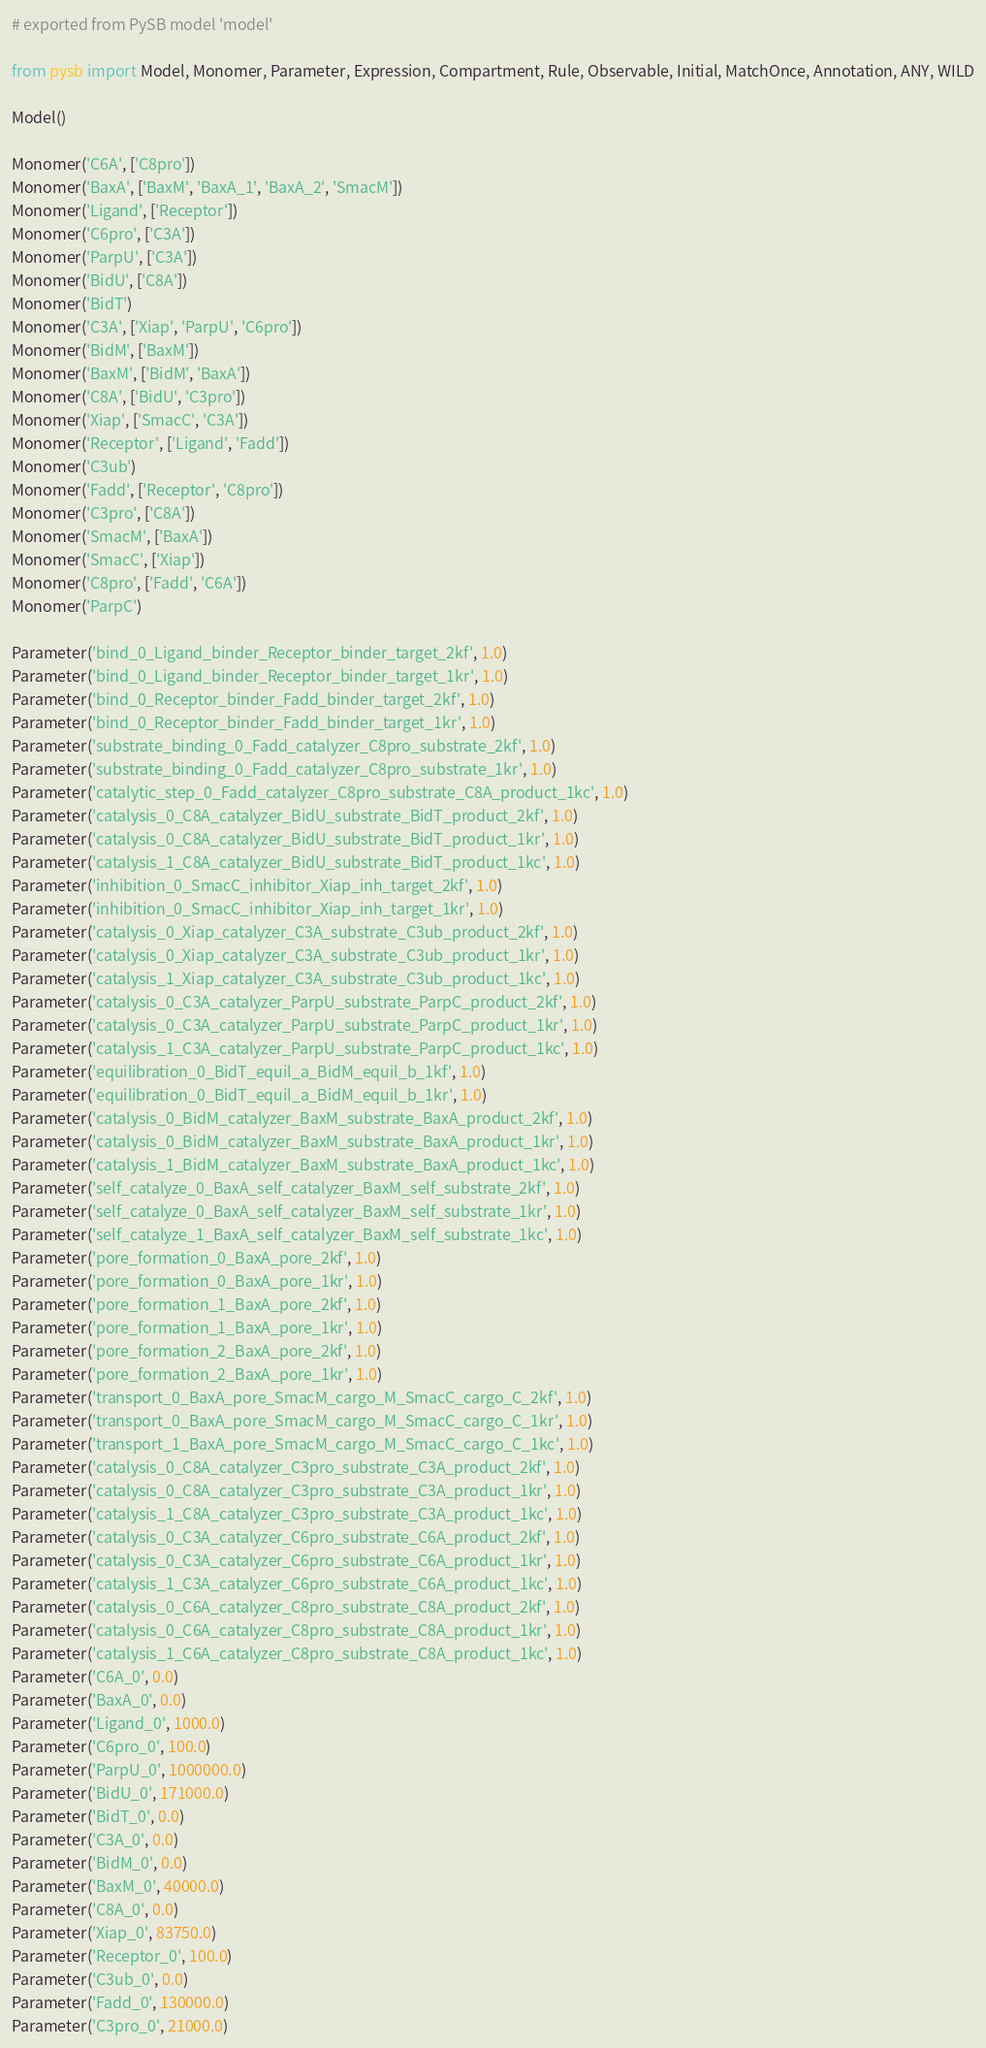<code> <loc_0><loc_0><loc_500><loc_500><_Python_># exported from PySB model 'model'

from pysb import Model, Monomer, Parameter, Expression, Compartment, Rule, Observable, Initial, MatchOnce, Annotation, ANY, WILD

Model()

Monomer('C6A', ['C8pro'])
Monomer('BaxA', ['BaxM', 'BaxA_1', 'BaxA_2', 'SmacM'])
Monomer('Ligand', ['Receptor'])
Monomer('C6pro', ['C3A'])
Monomer('ParpU', ['C3A'])
Monomer('BidU', ['C8A'])
Monomer('BidT')
Monomer('C3A', ['Xiap', 'ParpU', 'C6pro'])
Monomer('BidM', ['BaxM'])
Monomer('BaxM', ['BidM', 'BaxA'])
Monomer('C8A', ['BidU', 'C3pro'])
Monomer('Xiap', ['SmacC', 'C3A'])
Monomer('Receptor', ['Ligand', 'Fadd'])
Monomer('C3ub')
Monomer('Fadd', ['Receptor', 'C8pro'])
Monomer('C3pro', ['C8A'])
Monomer('SmacM', ['BaxA'])
Monomer('SmacC', ['Xiap'])
Monomer('C8pro', ['Fadd', 'C6A'])
Monomer('ParpC')

Parameter('bind_0_Ligand_binder_Receptor_binder_target_2kf', 1.0)
Parameter('bind_0_Ligand_binder_Receptor_binder_target_1kr', 1.0)
Parameter('bind_0_Receptor_binder_Fadd_binder_target_2kf', 1.0)
Parameter('bind_0_Receptor_binder_Fadd_binder_target_1kr', 1.0)
Parameter('substrate_binding_0_Fadd_catalyzer_C8pro_substrate_2kf', 1.0)
Parameter('substrate_binding_0_Fadd_catalyzer_C8pro_substrate_1kr', 1.0)
Parameter('catalytic_step_0_Fadd_catalyzer_C8pro_substrate_C8A_product_1kc', 1.0)
Parameter('catalysis_0_C8A_catalyzer_BidU_substrate_BidT_product_2kf', 1.0)
Parameter('catalysis_0_C8A_catalyzer_BidU_substrate_BidT_product_1kr', 1.0)
Parameter('catalysis_1_C8A_catalyzer_BidU_substrate_BidT_product_1kc', 1.0)
Parameter('inhibition_0_SmacC_inhibitor_Xiap_inh_target_2kf', 1.0)
Parameter('inhibition_0_SmacC_inhibitor_Xiap_inh_target_1kr', 1.0)
Parameter('catalysis_0_Xiap_catalyzer_C3A_substrate_C3ub_product_2kf', 1.0)
Parameter('catalysis_0_Xiap_catalyzer_C3A_substrate_C3ub_product_1kr', 1.0)
Parameter('catalysis_1_Xiap_catalyzer_C3A_substrate_C3ub_product_1kc', 1.0)
Parameter('catalysis_0_C3A_catalyzer_ParpU_substrate_ParpC_product_2kf', 1.0)
Parameter('catalysis_0_C3A_catalyzer_ParpU_substrate_ParpC_product_1kr', 1.0)
Parameter('catalysis_1_C3A_catalyzer_ParpU_substrate_ParpC_product_1kc', 1.0)
Parameter('equilibration_0_BidT_equil_a_BidM_equil_b_1kf', 1.0)
Parameter('equilibration_0_BidT_equil_a_BidM_equil_b_1kr', 1.0)
Parameter('catalysis_0_BidM_catalyzer_BaxM_substrate_BaxA_product_2kf', 1.0)
Parameter('catalysis_0_BidM_catalyzer_BaxM_substrate_BaxA_product_1kr', 1.0)
Parameter('catalysis_1_BidM_catalyzer_BaxM_substrate_BaxA_product_1kc', 1.0)
Parameter('self_catalyze_0_BaxA_self_catalyzer_BaxM_self_substrate_2kf', 1.0)
Parameter('self_catalyze_0_BaxA_self_catalyzer_BaxM_self_substrate_1kr', 1.0)
Parameter('self_catalyze_1_BaxA_self_catalyzer_BaxM_self_substrate_1kc', 1.0)
Parameter('pore_formation_0_BaxA_pore_2kf', 1.0)
Parameter('pore_formation_0_BaxA_pore_1kr', 1.0)
Parameter('pore_formation_1_BaxA_pore_2kf', 1.0)
Parameter('pore_formation_1_BaxA_pore_1kr', 1.0)
Parameter('pore_formation_2_BaxA_pore_2kf', 1.0)
Parameter('pore_formation_2_BaxA_pore_1kr', 1.0)
Parameter('transport_0_BaxA_pore_SmacM_cargo_M_SmacC_cargo_C_2kf', 1.0)
Parameter('transport_0_BaxA_pore_SmacM_cargo_M_SmacC_cargo_C_1kr', 1.0)
Parameter('transport_1_BaxA_pore_SmacM_cargo_M_SmacC_cargo_C_1kc', 1.0)
Parameter('catalysis_0_C8A_catalyzer_C3pro_substrate_C3A_product_2kf', 1.0)
Parameter('catalysis_0_C8A_catalyzer_C3pro_substrate_C3A_product_1kr', 1.0)
Parameter('catalysis_1_C8A_catalyzer_C3pro_substrate_C3A_product_1kc', 1.0)
Parameter('catalysis_0_C3A_catalyzer_C6pro_substrate_C6A_product_2kf', 1.0)
Parameter('catalysis_0_C3A_catalyzer_C6pro_substrate_C6A_product_1kr', 1.0)
Parameter('catalysis_1_C3A_catalyzer_C6pro_substrate_C6A_product_1kc', 1.0)
Parameter('catalysis_0_C6A_catalyzer_C8pro_substrate_C8A_product_2kf', 1.0)
Parameter('catalysis_0_C6A_catalyzer_C8pro_substrate_C8A_product_1kr', 1.0)
Parameter('catalysis_1_C6A_catalyzer_C8pro_substrate_C8A_product_1kc', 1.0)
Parameter('C6A_0', 0.0)
Parameter('BaxA_0', 0.0)
Parameter('Ligand_0', 1000.0)
Parameter('C6pro_0', 100.0)
Parameter('ParpU_0', 1000000.0)
Parameter('BidU_0', 171000.0)
Parameter('BidT_0', 0.0)
Parameter('C3A_0', 0.0)
Parameter('BidM_0', 0.0)
Parameter('BaxM_0', 40000.0)
Parameter('C8A_0', 0.0)
Parameter('Xiap_0', 83750.0)
Parameter('Receptor_0', 100.0)
Parameter('C3ub_0', 0.0)
Parameter('Fadd_0', 130000.0)
Parameter('C3pro_0', 21000.0)</code> 